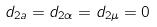Convert formula to latex. <formula><loc_0><loc_0><loc_500><loc_500>d _ { 2 a } = d _ { 2 \alpha } = d _ { 2 \mu } = 0</formula> 